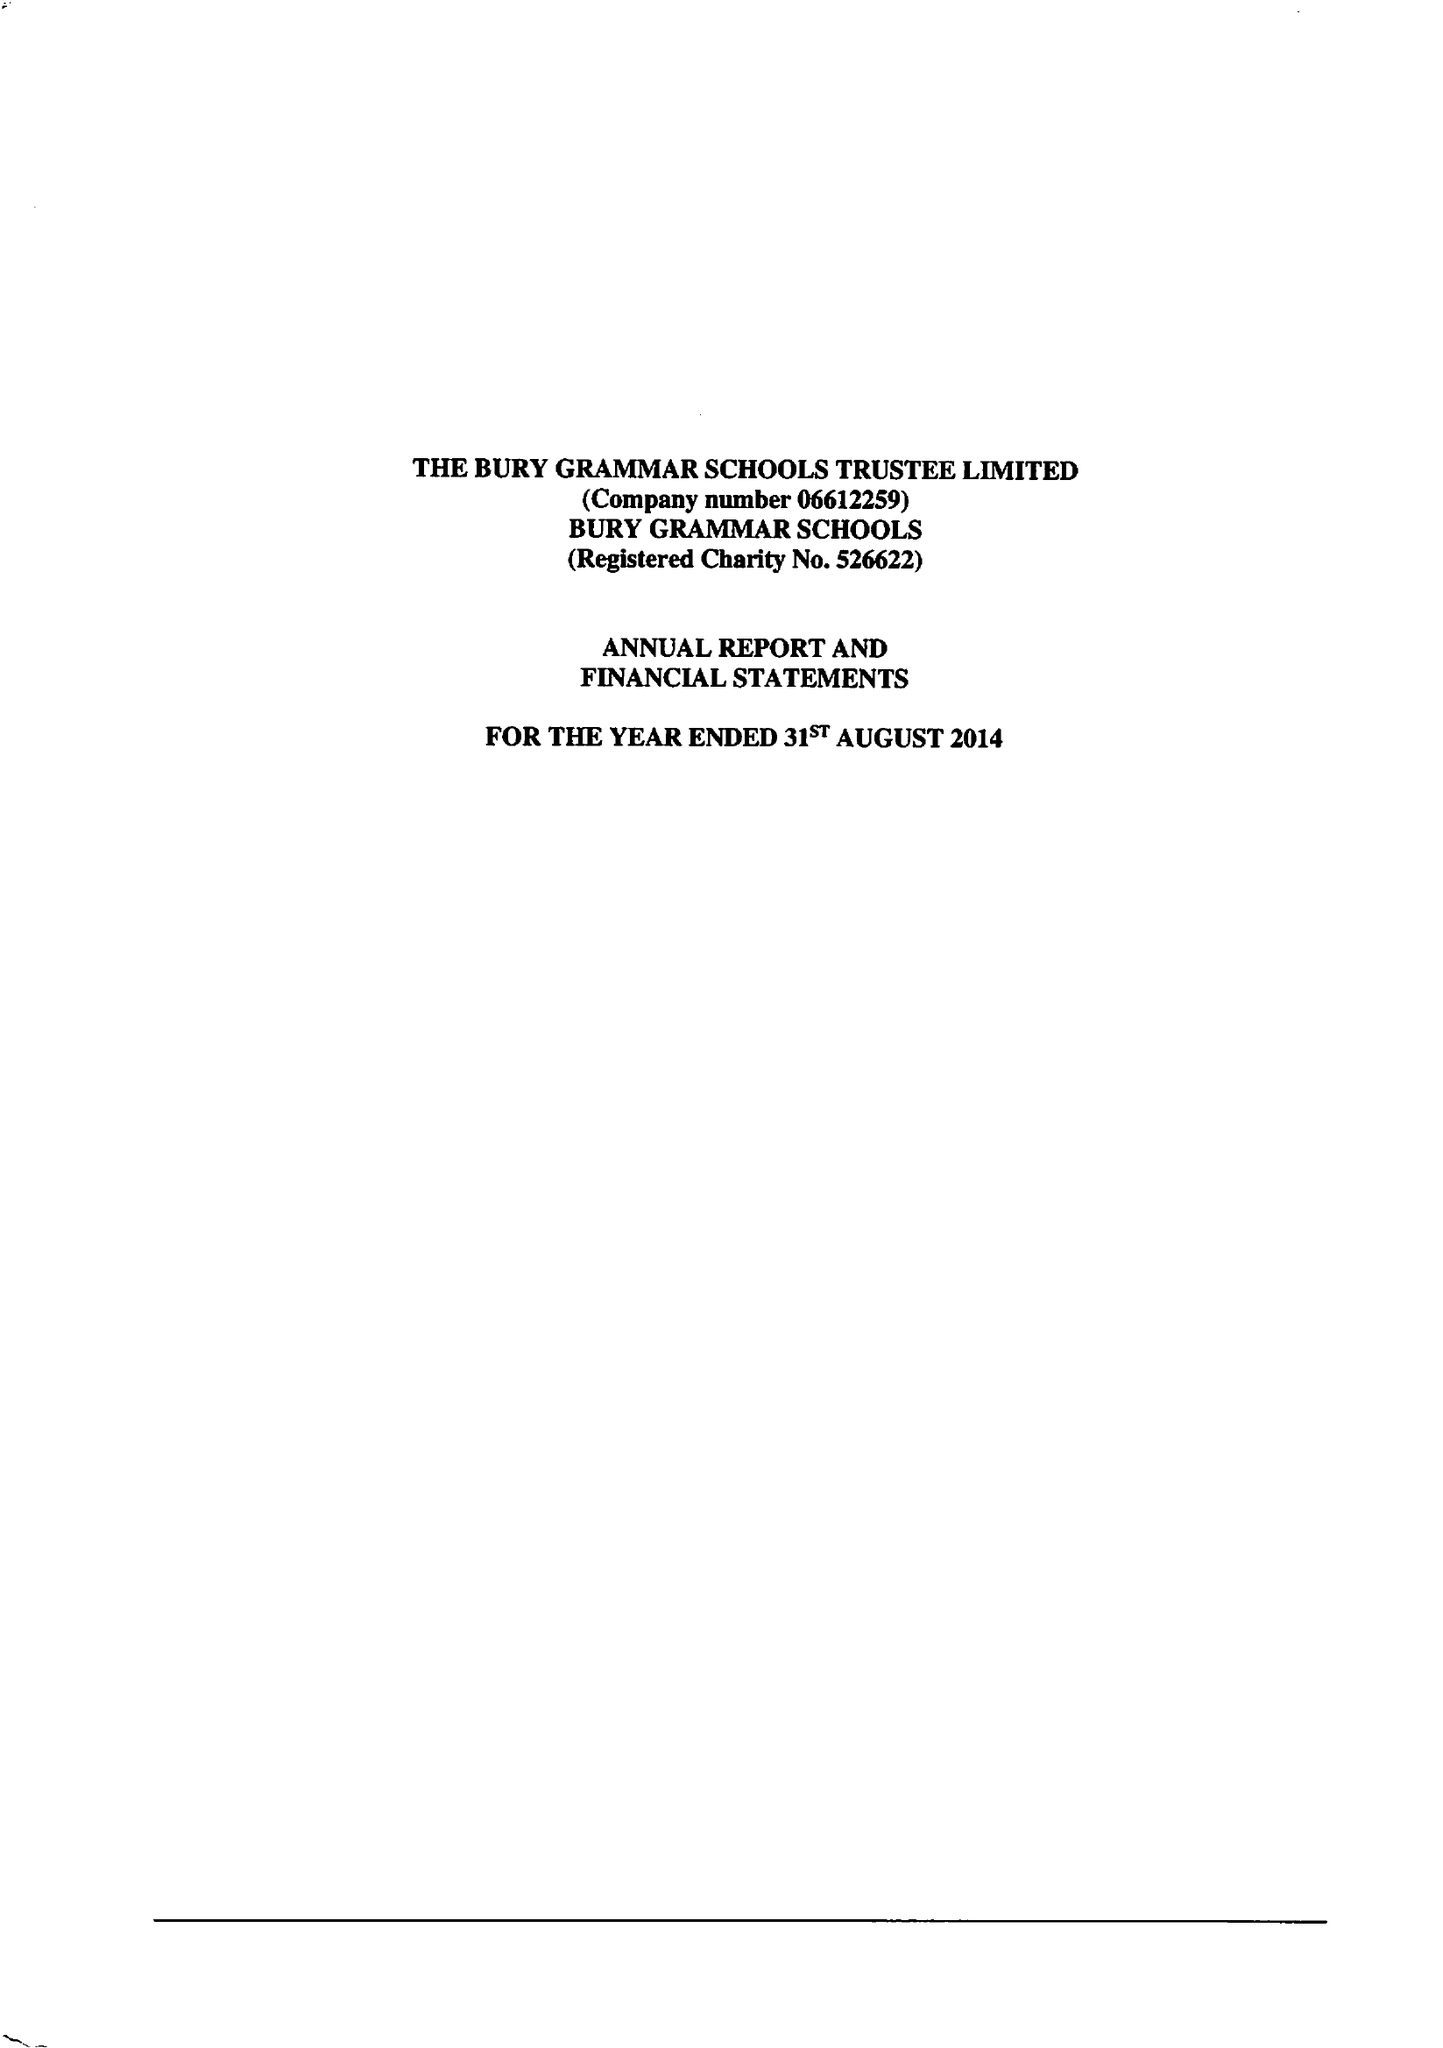What is the value for the report_date?
Answer the question using a single word or phrase. 2014-08-31 